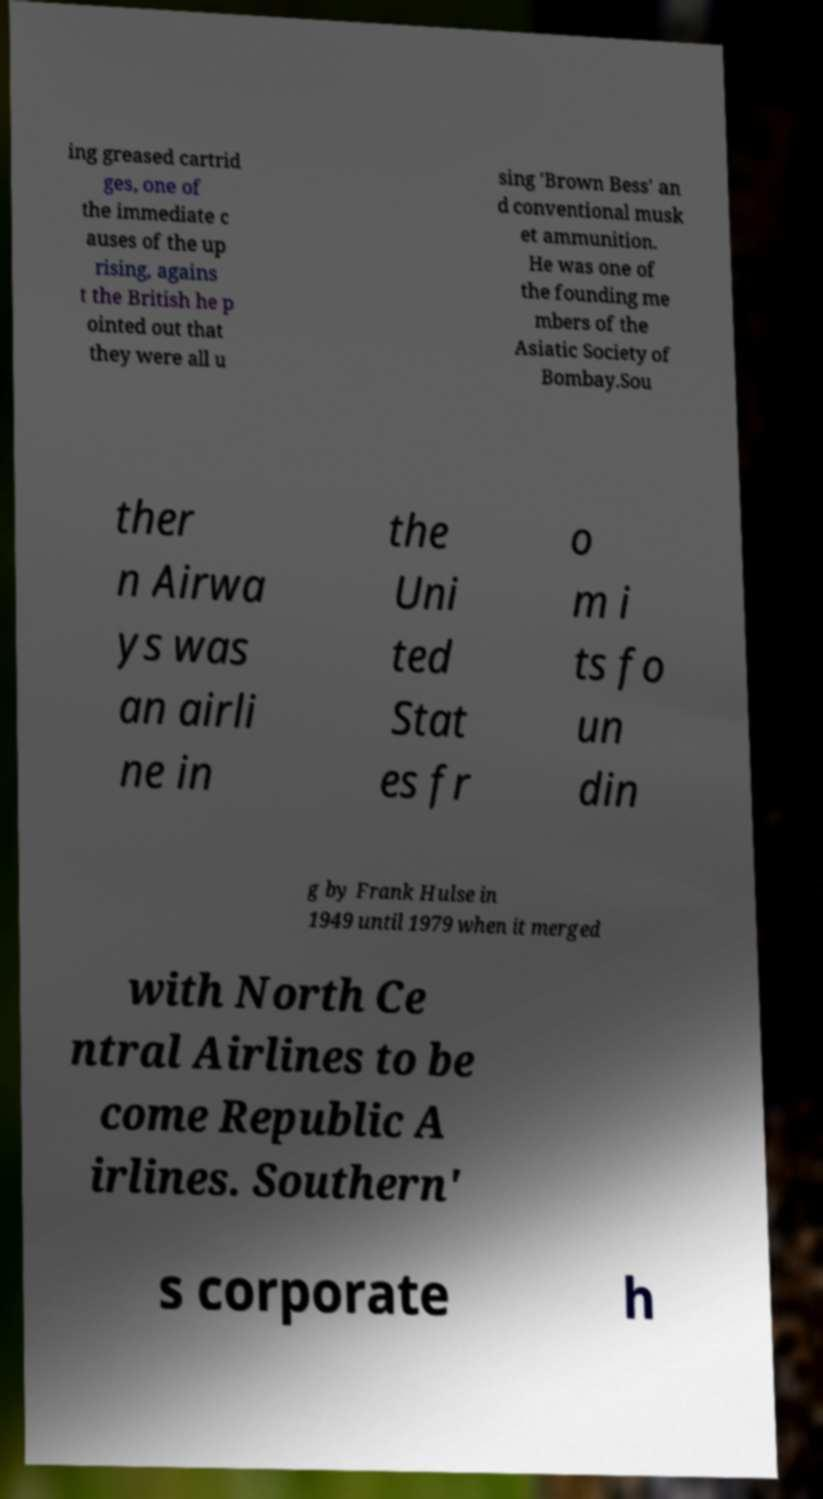Could you assist in decoding the text presented in this image and type it out clearly? ing greased cartrid ges, one of the immediate c auses of the up rising, agains t the British he p ointed out that they were all u sing 'Brown Bess' an d conventional musk et ammunition. He was one of the founding me mbers of the Asiatic Society of Bombay.Sou ther n Airwa ys was an airli ne in the Uni ted Stat es fr o m i ts fo un din g by Frank Hulse in 1949 until 1979 when it merged with North Ce ntral Airlines to be come Republic A irlines. Southern' s corporate h 